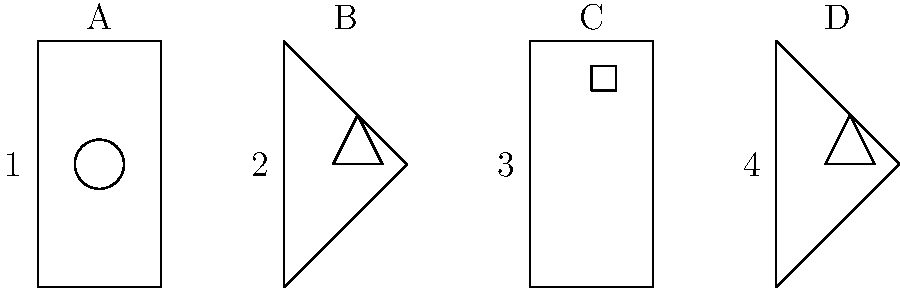Match the state outlines (1-4) with their corresponding iconic historical landmarks (A-D). Which combination correctly pairs all states with their landmarks? To solve this question, we need to identify each state outline and its corresponding landmark. Let's go through them step-by-step:

1. State outline 1 is a rectangle, which resembles Texas. The landmark A is a circle, representing the Alamo in San Antonio, Texas.

2. State outline 2 is a triangle-like shape, resembling Florida's peninsula. Landmark B is a triangle pointing upward, representing the Kennedy Space Center in Florida.

3. State outline 3 is a tall rectangle, similar to New York state. Landmark C is a small rectangle on top, representing the Statue of Liberty in New York Harbor.

4. State outline 4 is another triangle-like shape, resembling California. Landmark D is a triangle with a flat bottom, representing the Golden Gate Bridge in San Francisco, California.

Therefore, the correct pairing is:
1-A (Texas - Alamo)
2-B (Florida - Kennedy Space Center)
3-C (New York - Statue of Liberty)
4-D (California - Golden Gate Bridge)
Answer: 1-A, 2-B, 3-C, 4-D 